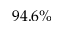<formula> <loc_0><loc_0><loc_500><loc_500>9 4 . 6 \%</formula> 